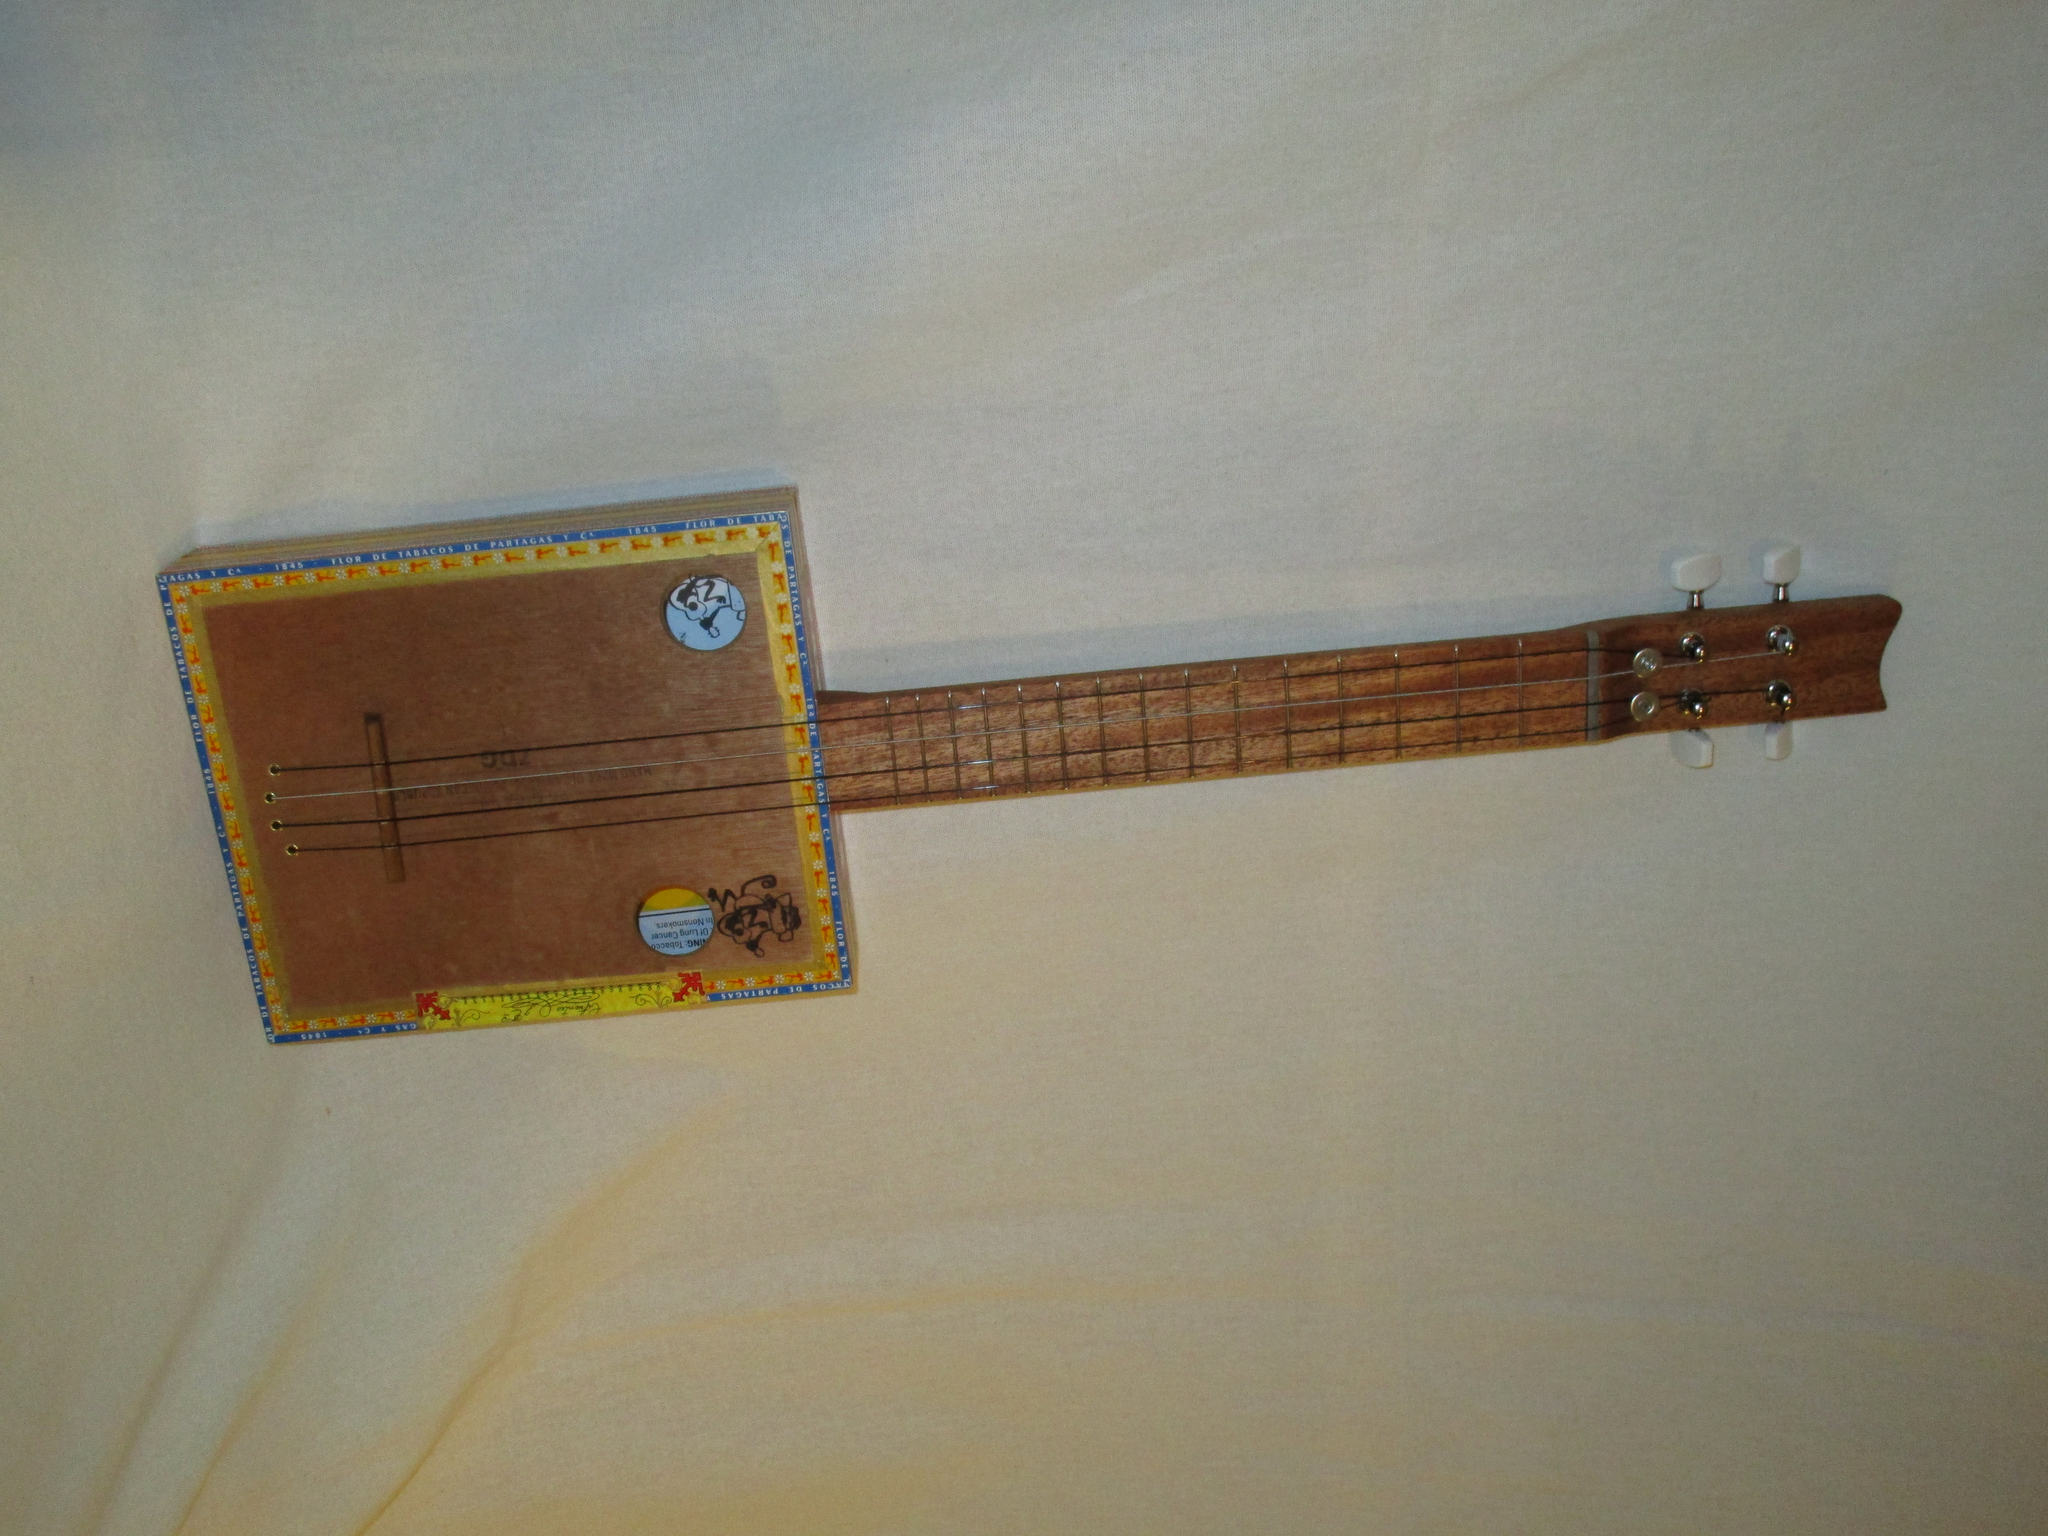Describe this image in one or two sentences. In this image there is a guitar , in the background there is a white curtain. 